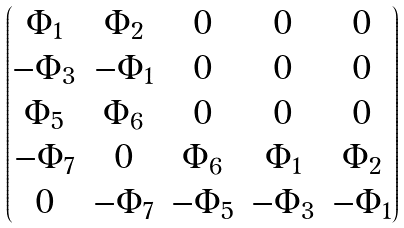<formula> <loc_0><loc_0><loc_500><loc_500>\begin{pmatrix} \Phi _ { 1 } & \Phi _ { 2 } & 0 & 0 & 0 \\ - \Phi _ { 3 } & - \Phi _ { 1 } & 0 & 0 & 0 \\ \Phi _ { 5 } & \Phi _ { 6 } & 0 & 0 & 0 \\ - \Phi _ { 7 } & 0 & \Phi _ { 6 } & \Phi _ { 1 } & \Phi _ { 2 } \\ 0 & - \Phi _ { 7 } & - \Phi _ { 5 } & - \Phi _ { 3 } & - \Phi _ { 1 } \end{pmatrix}</formula> 